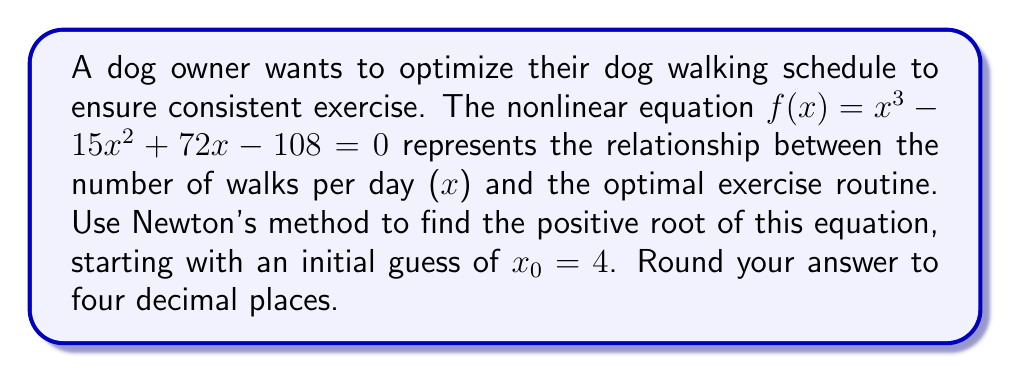What is the answer to this math problem? To solve this problem using Newton's method, we follow these steps:

1) Newton's method is given by the formula:

   $$x_{n+1} = x_n - \frac{f(x_n)}{f'(x_n)}$$

2) We have $f(x) = x^3 - 15x^2 + 72x - 108$
   The derivative is $f'(x) = 3x^2 - 30x + 72$

3) Starting with $x_0 = 4$, we iterate:

   Iteration 1:
   $$f(4) = 4^3 - 15(4^2) + 72(4) - 108 = 64 - 240 + 288 - 108 = 4$$
   $$f'(4) = 3(4^2) - 30(4) + 72 = 48 - 120 + 72 = 0$$

   Since $f'(4) = 0$, we can't proceed with this initial guess as it would lead to division by zero.

4) Let's try a different initial guess, $x_0 = 5$:

   Iteration 1:
   $$f(5) = 5^3 - 15(5^2) + 72(5) - 108 = 125 - 375 + 360 - 108 = 2$$
   $$f'(5) = 3(5^2) - 30(5) + 72 = 75 - 150 + 72 = -3$$
   $$x_1 = 5 - \frac{2}{-3} = 5 + \frac{2}{3} \approx 5.6667$$

   Iteration 2:
   $$f(5.6667) \approx 0.2963$$
   $$f'(5.6667) \approx -8.6667$$
   $$x_2 \approx 5.6667 - \frac{0.2963}{-8.6667} \approx 5.6324$$

   Iteration 3:
   $$f(5.6324) \approx 0.0007$$
   $$f'(5.6324) \approx -9.3946$$
   $$x_3 \approx 5.6324 - \frac{0.0007}{-9.3946} \approx 5.6324$$

5) The process converges to 5.6324 (rounded to 4 decimal places).
Answer: 5.6324 